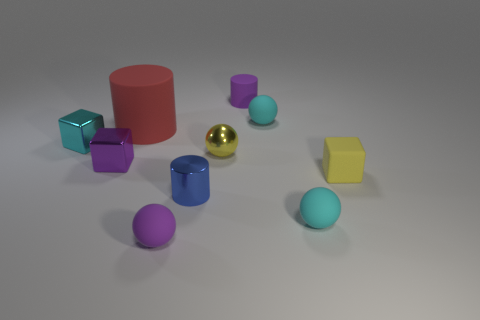There is a tiny matte sphere that is to the left of the tiny matte cylinder; is its color the same as the tiny matte cylinder?
Offer a very short reply. Yes. Are there any other tiny things of the same shape as the yellow shiny thing?
Keep it short and to the point. Yes. There is a cyan object to the left of the purple cylinder; what size is it?
Make the answer very short. Small. There is a purple object that is in front of the tiny yellow rubber cube; is there a small cyan thing that is to the left of it?
Offer a terse response. Yes. Are the cube on the right side of the large red thing and the small purple cube made of the same material?
Keep it short and to the point. No. What number of purple objects are to the right of the small purple shiny cube and in front of the large cylinder?
Provide a succinct answer. 1. How many objects are the same material as the big cylinder?
Offer a very short reply. 5. The cylinder that is made of the same material as the small yellow ball is what color?
Your response must be concise. Blue. Are there fewer purple spheres than small rubber things?
Your response must be concise. Yes. The small yellow object right of the purple matte thing that is right of the sphere that is to the left of the blue object is made of what material?
Give a very brief answer. Rubber. 